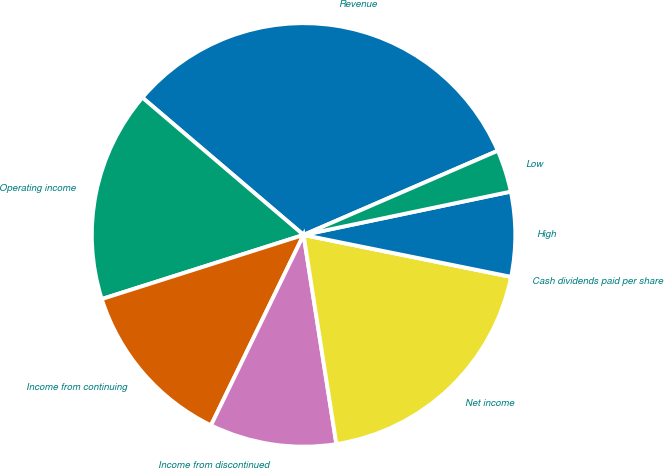Convert chart. <chart><loc_0><loc_0><loc_500><loc_500><pie_chart><fcel>Revenue<fcel>Operating income<fcel>Income from continuing<fcel>Income from discontinued<fcel>Net income<fcel>Cash dividends paid per share<fcel>High<fcel>Low<nl><fcel>32.26%<fcel>16.13%<fcel>12.9%<fcel>9.68%<fcel>19.35%<fcel>0.0%<fcel>6.45%<fcel>3.23%<nl></chart> 